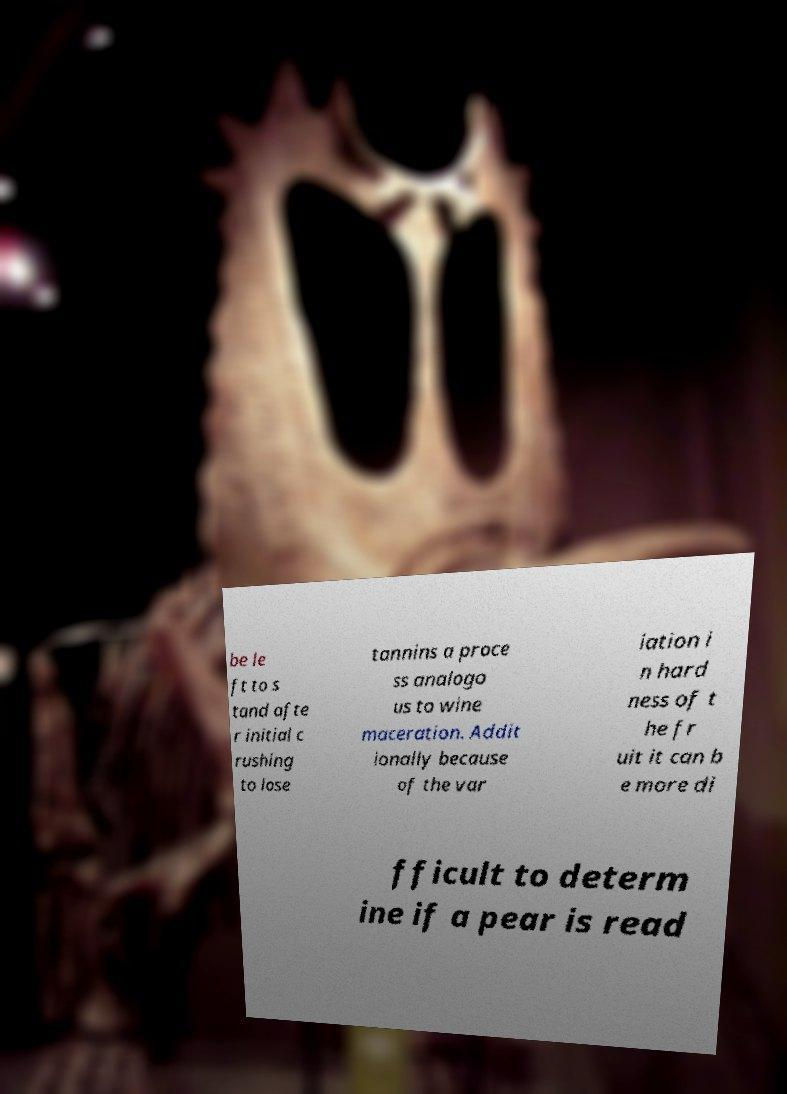I need the written content from this picture converted into text. Can you do that? be le ft to s tand afte r initial c rushing to lose tannins a proce ss analogo us to wine maceration. Addit ionally because of the var iation i n hard ness of t he fr uit it can b e more di fficult to determ ine if a pear is read 